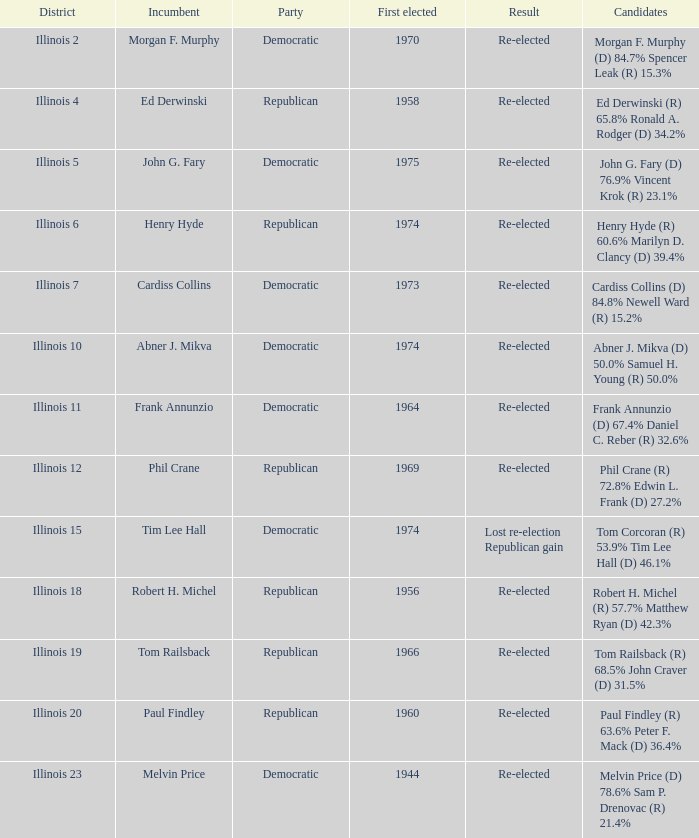Name the number of first elected for phil crane 1.0. 